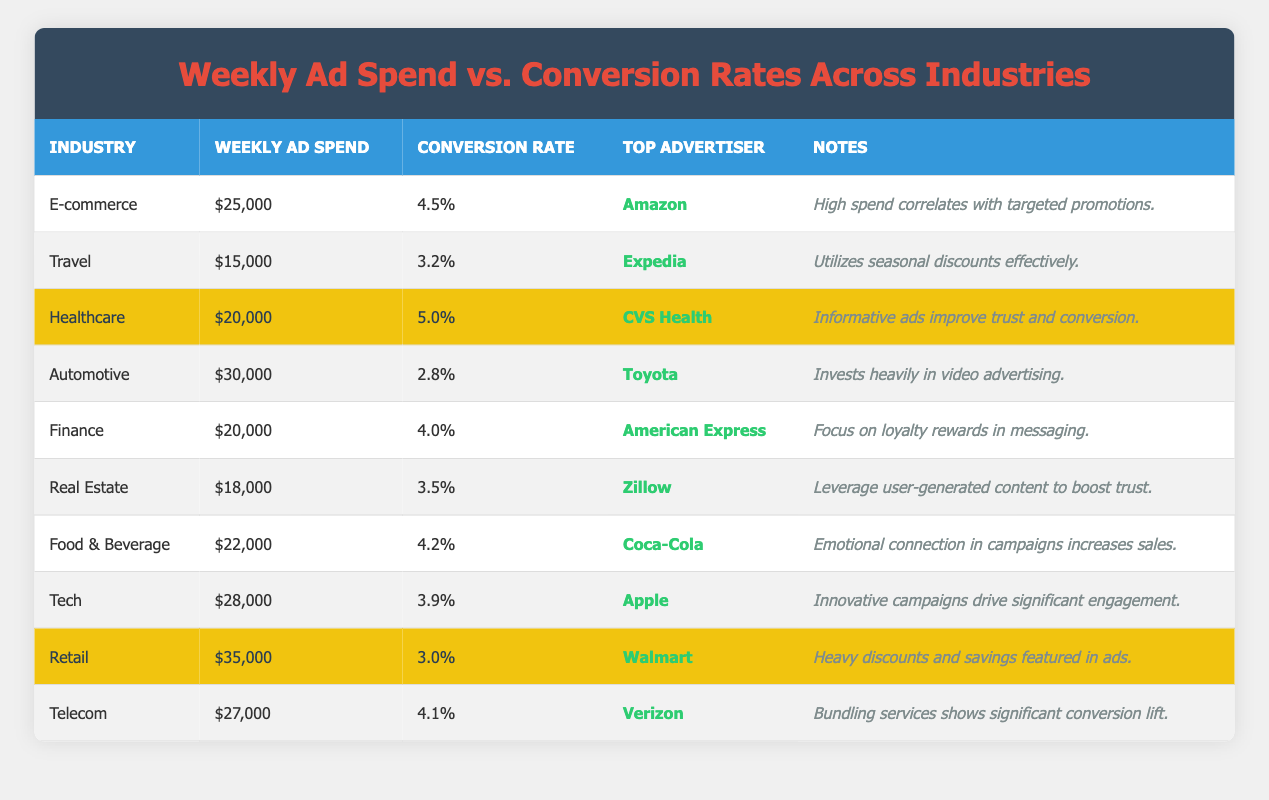What industry has the highest weekly ad spend? By scanning the table, the automotive industry shows a weekly ad spend of $30,000, which is the maximum among all industries listed.
Answer: Automotive What is the conversion rate for the healthcare industry? According to the table, the healthcare industry's conversion rate is listed as 5.0%.
Answer: 5.0% Which top advertiser operates in the travel industry? Looking at the travel industry row in the table, it shows that Expedia is the top advertiser.
Answer: Expedia What is the average weekly ad spend across all industries? To calculate, we add the weekly ad spends of all industries: 25000 + 15000 + 20000 + 30000 + 20000 + 18000 + 22000 + 28000 + 35000 + 27000 = 215000. Dividing this sum by the number of industries (10) gives us an average of 215000/10 = 21500.
Answer: 21500 Is the conversion rate for food & beverage greater than 4%? The food & beverage section shows a conversion rate of 4.2%, which is indeed greater than 4%.
Answer: Yes Which industry has the lowest conversion rate? The industry with the lowest conversion rate can be identified by comparing the rates listed, with the automotive industry showing a conversion rate of 2.8%, which is the lowest compared to the others.
Answer: Automotive What is the difference in conversion rates between tech and telecom? The conversion rate for tech is 3.9% and for telecom is 4.1%. The difference is 4.1% - 3.9% = 0.2%.
Answer: 0.2% How many industries have a conversion rate of 4% or higher? By counting the entries with conversion rates of 4% and above in the table, there are four: healthcare (5.0%), e-commerce (4.5%), finance (4.0%), and telecom (4.1%). Therefore, the total count is 4.
Answer: 4 What insights can be drawn about the relationship between weekly ad spend and conversion rates based on the table? Based on the data, high ad spends do not necessarily guarantee high conversion rates, as seen with automotive and retail, which have higher spends but lower conversion rates. Conversely, healthcare has a significant conversion rate with a moderate ad spend. This indicates that targeting and advertising quality may play a crucial role.
Answer: High spend does not guarantee high conversion; targeting matters 